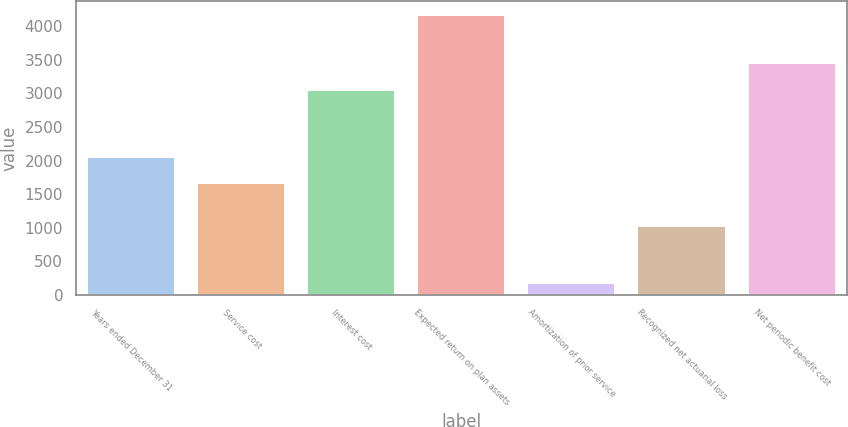Convert chart. <chart><loc_0><loc_0><loc_500><loc_500><bar_chart><fcel>Years ended December 31<fcel>Service cost<fcel>Interest cost<fcel>Expected return on plan assets<fcel>Amortization of prior service<fcel>Recognized net actuarial loss<fcel>Net periodic benefit cost<nl><fcel>2060.2<fcel>1661<fcel>3058<fcel>4169<fcel>177<fcel>1020<fcel>3457.2<nl></chart> 